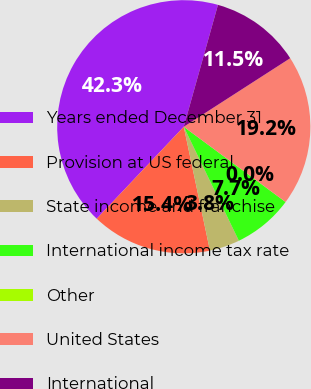Convert chart. <chart><loc_0><loc_0><loc_500><loc_500><pie_chart><fcel>Years ended December 31<fcel>Provision at US federal<fcel>State income and franchise<fcel>International income tax rate<fcel>Other<fcel>United States<fcel>International<nl><fcel>42.29%<fcel>15.38%<fcel>3.85%<fcel>7.7%<fcel>0.01%<fcel>19.23%<fcel>11.54%<nl></chart> 